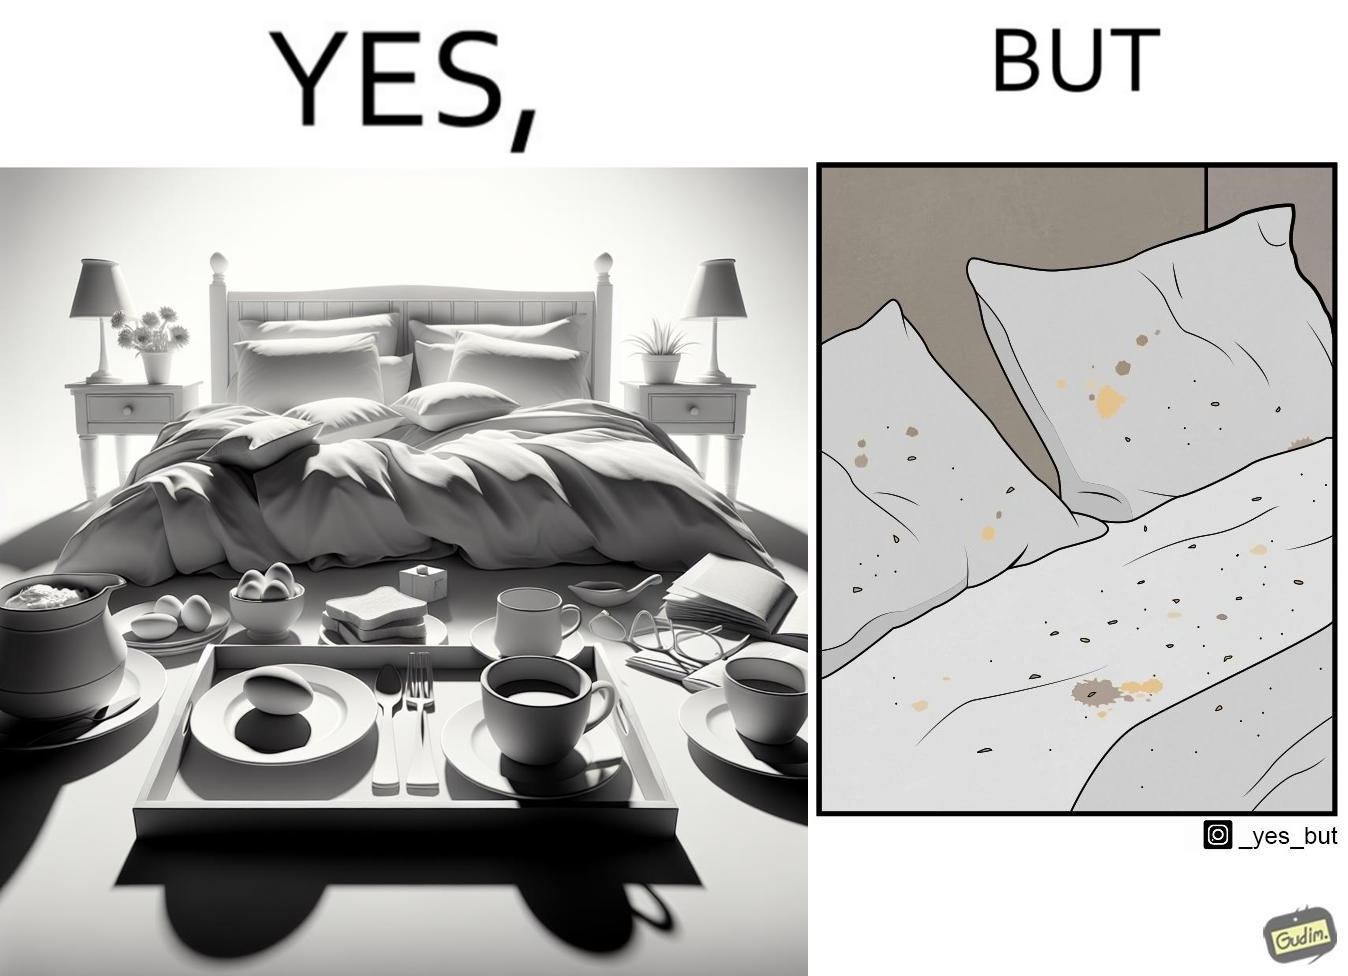Explain why this image is satirical. The image is ironical, as having breakfast in bed is a luxury. However, eating while in bed leads to food crumbs, making the bed dirty, along with the need to clean the bed afterwards. 